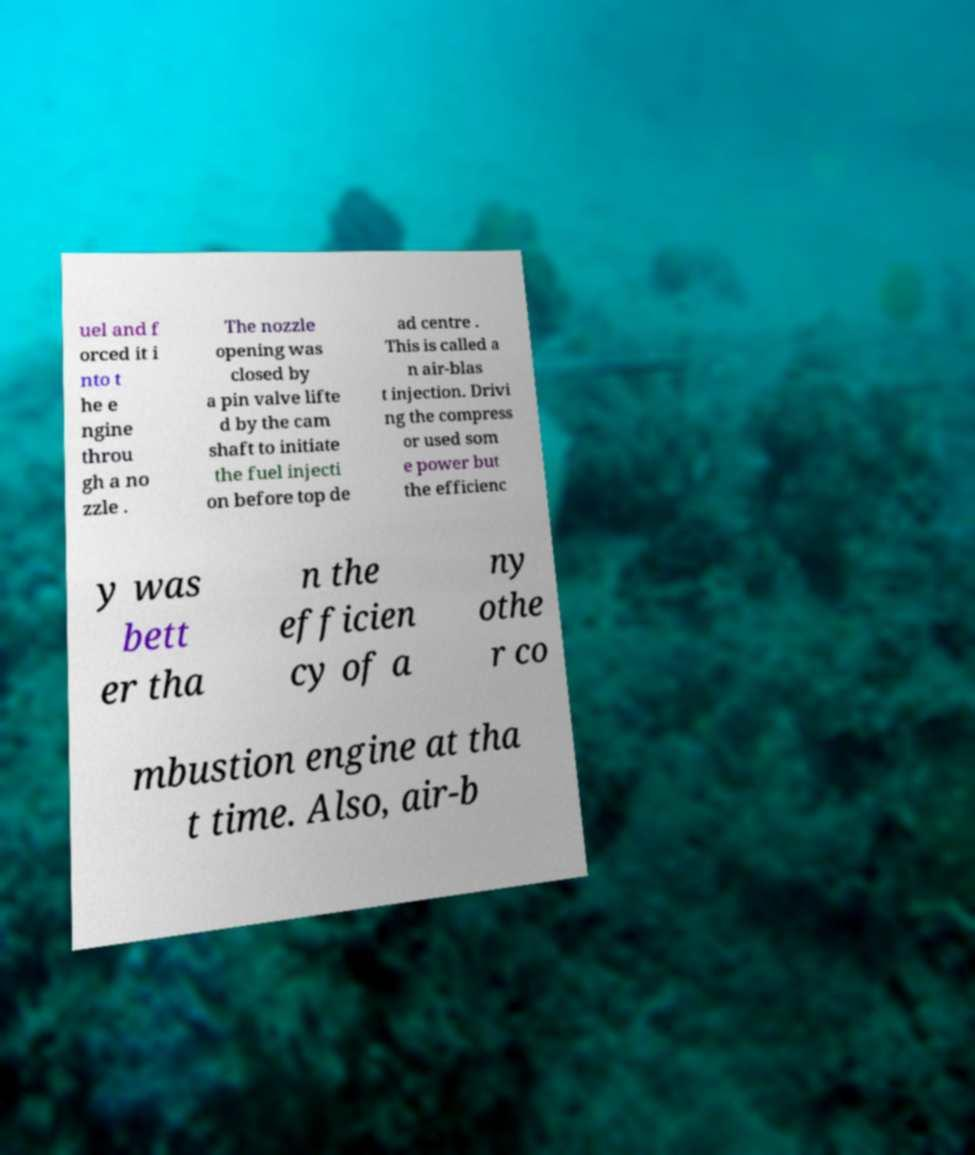Can you read and provide the text displayed in the image?This photo seems to have some interesting text. Can you extract and type it out for me? uel and f orced it i nto t he e ngine throu gh a no zzle . The nozzle opening was closed by a pin valve lifte d by the cam shaft to initiate the fuel injecti on before top de ad centre . This is called a n air-blas t injection. Drivi ng the compress or used som e power but the efficienc y was bett er tha n the efficien cy of a ny othe r co mbustion engine at tha t time. Also, air-b 